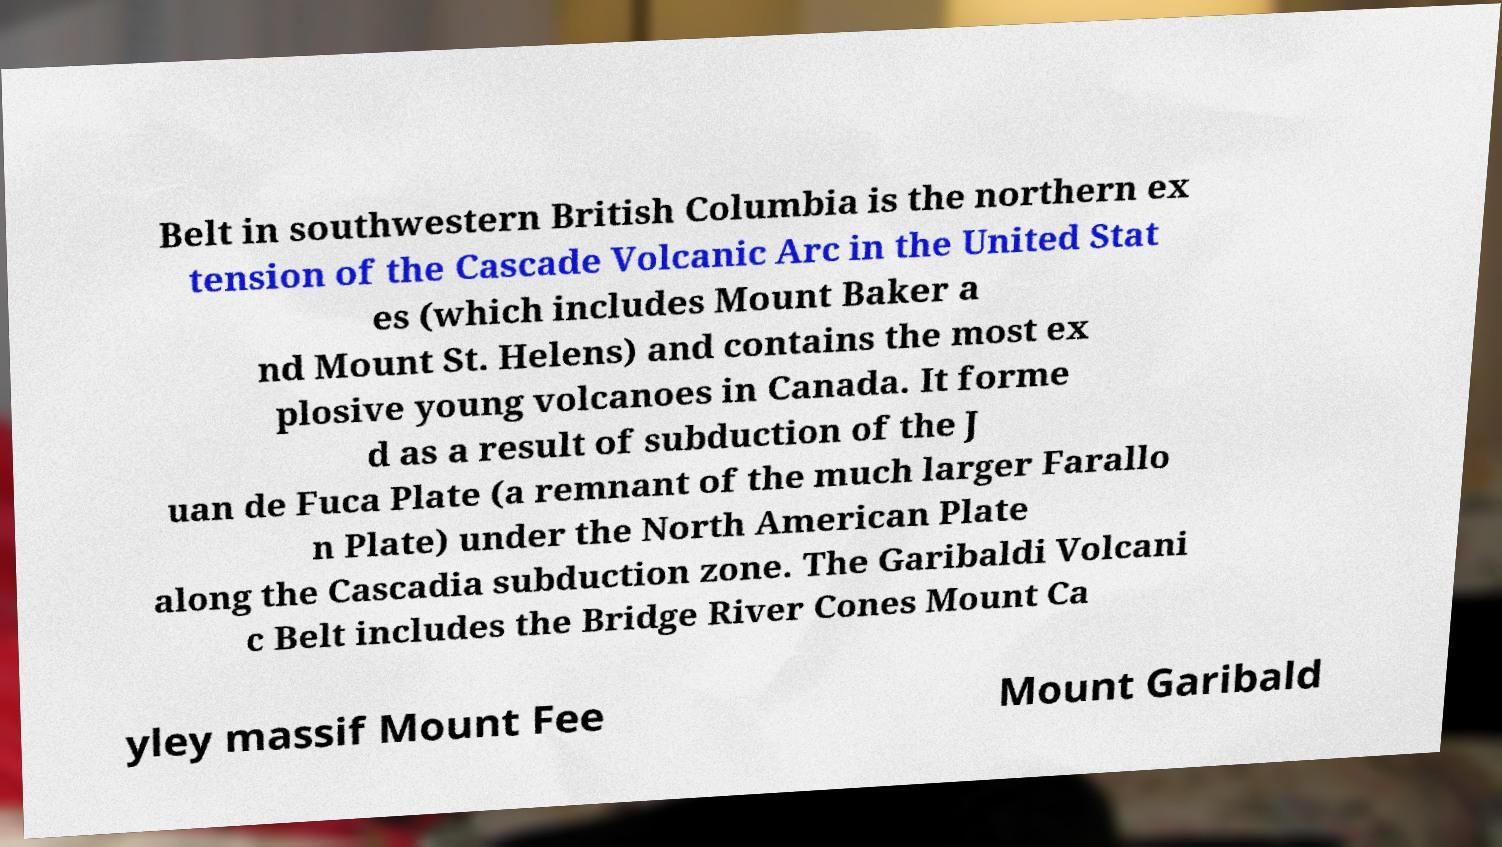Please read and relay the text visible in this image. What does it say? Belt in southwestern British Columbia is the northern ex tension of the Cascade Volcanic Arc in the United Stat es (which includes Mount Baker a nd Mount St. Helens) and contains the most ex plosive young volcanoes in Canada. It forme d as a result of subduction of the J uan de Fuca Plate (a remnant of the much larger Farallo n Plate) under the North American Plate along the Cascadia subduction zone. The Garibaldi Volcani c Belt includes the Bridge River Cones Mount Ca yley massif Mount Fee Mount Garibald 